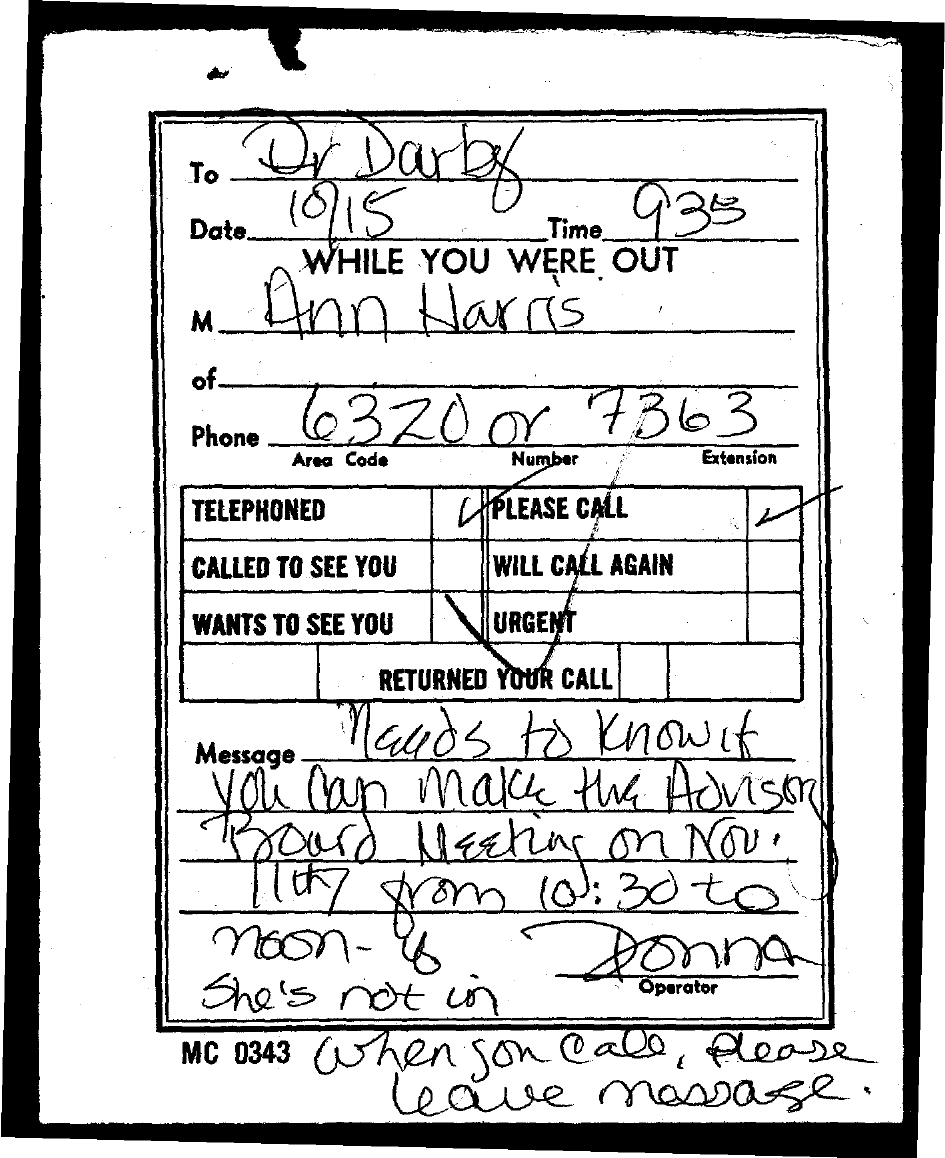Highlight a few significant elements in this photo. What is the date? The date is currently 10/15. The person addressed in this message is Dr. Darby. The message is from Ann Harris. The time is currently 9:35. 